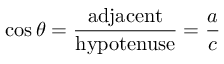<formula> <loc_0><loc_0><loc_500><loc_500>\cos \theta = { \frac { a d j a c e n t } { h y p o t e n u s e } } = { \frac { a } { c } }</formula> 